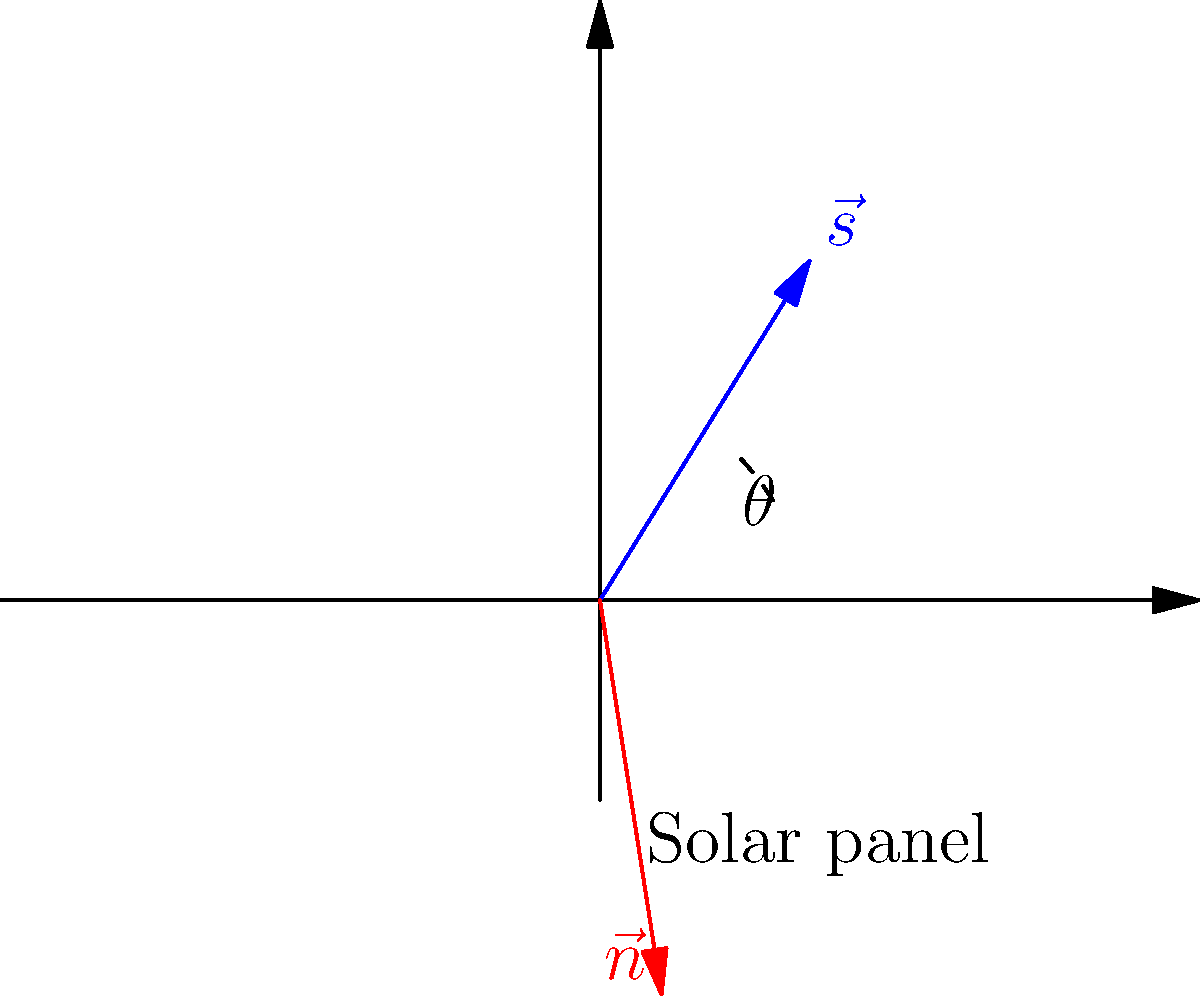In your small Norwegian town, you're curious about optimizing solar panel efficiency. Given that the sun's rays can be represented by vector $\vec{s} = (\frac{\sqrt{2}}{2}, \frac{\sqrt{2}}{2})$ and the solar panel's normal vector is $\vec{n} = (\frac{\sqrt{3}}{2}, \frac{1}{2})$, what is the angle $\theta$ (in degrees) between these vectors? How does this affect the solar panel's efficiency? To solve this problem, we'll use the dot product formula and the relationship between dot product and angle. Here's a step-by-step explanation:

1) The dot product formula for two vectors $\vec{a}$ and $\vec{b}$ is:
   $\vec{a} \cdot \vec{b} = |\vec{a}||\vec{b}|\cos\theta$

2) We can also calculate the dot product using vector components:
   $\vec{a} \cdot \vec{b} = a_x b_x + a_y b_y$

3) Let's calculate the dot product of $\vec{s}$ and $\vec{n}$:
   $\vec{s} \cdot \vec{n} = (\frac{\sqrt{2}}{2} \cdot \frac{\sqrt{3}}{2}) + (\frac{\sqrt{2}}{2} \cdot \frac{1}{2}) = \frac{\sqrt{6}}{4} + \frac{\sqrt{2}}{4}$

4) Now, let's calculate the magnitudes of $\vec{s}$ and $\vec{n}$:
   $|\vec{s}| = \sqrt{(\frac{\sqrt{2}}{2})^2 + (\frac{\sqrt{2}}{2})^2} = 1$
   $|\vec{n}| = \sqrt{(\frac{\sqrt{3}}{2})^2 + (\frac{1}{2})^2} = 1$

5) Substituting into the dot product formula:
   $\frac{\sqrt{6}}{4} + \frac{\sqrt{2}}{4} = 1 \cdot 1 \cdot \cos\theta$

6) Solving for $\theta$:
   $\theta = \arccos(\frac{\sqrt{6}}{4} + \frac{\sqrt{2}}{4}) \approx 15°$

7) The efficiency of a solar panel is highest when the angle between the sun's rays and the panel's normal vector is 0°. As this angle increases, the efficiency decreases according to the cosine of the angle.

8) In this case, the 15° angle means the panel is receiving $\cos(15°) \approx 0.97$ or 97% of the maximum possible solar energy.
Answer: $15°$; 97% efficiency 